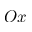<formula> <loc_0><loc_0><loc_500><loc_500>O x</formula> 